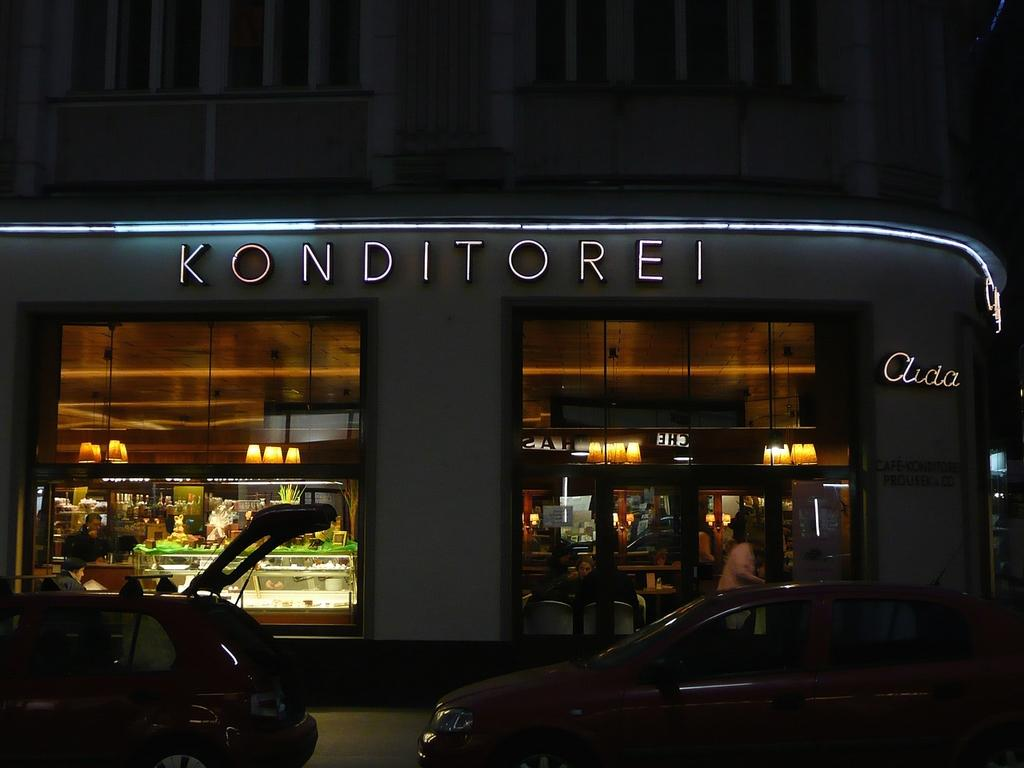What can be seen on the road in the image? There are vehicles on the road in the image. What structure is located beside the road? There is a building beside the road in the image. Can you identify any living beings in the image? Yes, there are people visible in the image. What type of signs are present in the image? Name boards are present in the image. What can be seen illuminating the scene in the image? Lights are visible in the image. Are there any other objects or features in the image? Yes, there are other objects in the image. How many geese are present in the image? There are no geese present in the image. What type of chain is holding the building together in the image? There is no chain holding the building together in the image; it is a solid structure. 